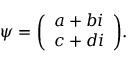Convert formula to latex. <formula><loc_0><loc_0><loc_500><loc_500>\psi = { \left ( \begin{array} { l } { a + b i } \\ { c + d i } \end{array} \right ) } .</formula> 